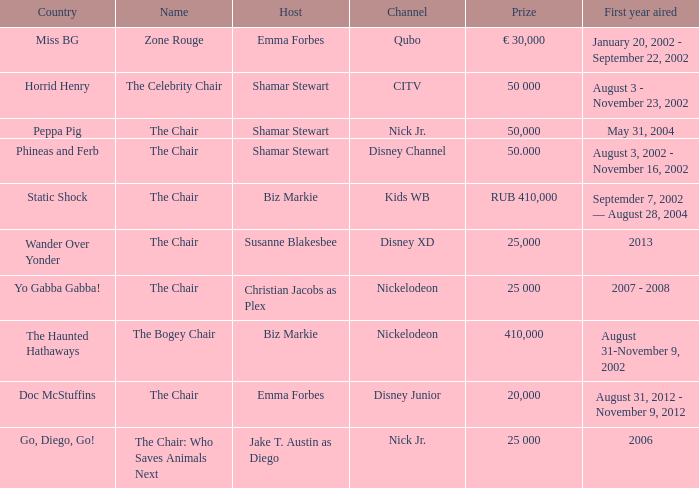What was the first year that had a prize of 50,000? May 31, 2004. 